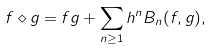Convert formula to latex. <formula><loc_0><loc_0><loc_500><loc_500>f \diamond g = f g + \sum _ { n \geq 1 } h ^ { n } B _ { n } ( f , g ) ,</formula> 